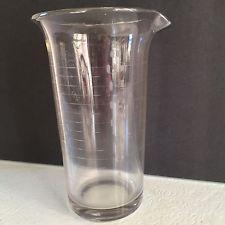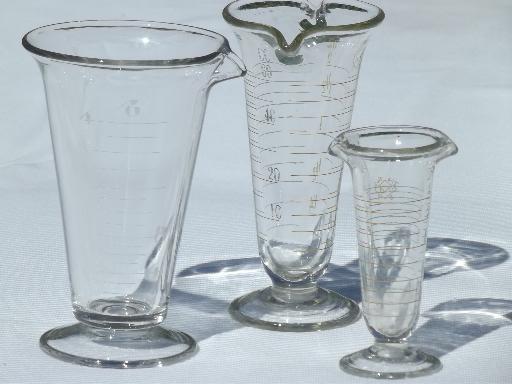The first image is the image on the left, the second image is the image on the right. Considering the images on both sides, is "The left and right image contains the same number of beakers." valid? Answer yes or no. No. The first image is the image on the left, the second image is the image on the right. Given the left and right images, does the statement "One image shows two footed beakers of the same height and one shorter footed beaker, all displayed upright." hold true? Answer yes or no. Yes. 